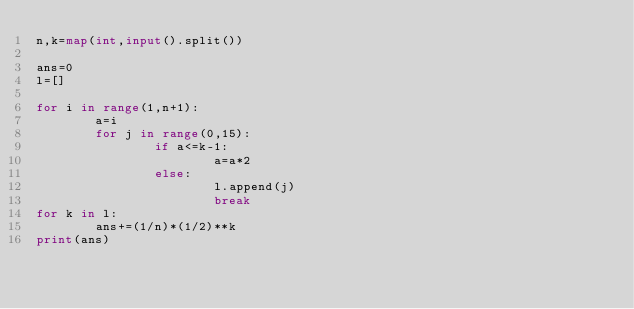Convert code to text. <code><loc_0><loc_0><loc_500><loc_500><_Python_>n,k=map(int,input().split())

ans=0
l=[]

for i in range(1,n+1):
        a=i
        for j in range(0,15):
                if a<=k-1:
                        a=a*2
                else:
                        l.append(j)
                        break
for k in l:
        ans+=(1/n)*(1/2)**k
print(ans)

        


</code> 